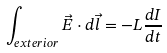Convert formula to latex. <formula><loc_0><loc_0><loc_500><loc_500>\int _ { e x t e r i o r } { \vec { E } } \cdot d { \vec { l } } = - L { \frac { d I } { d t } }</formula> 